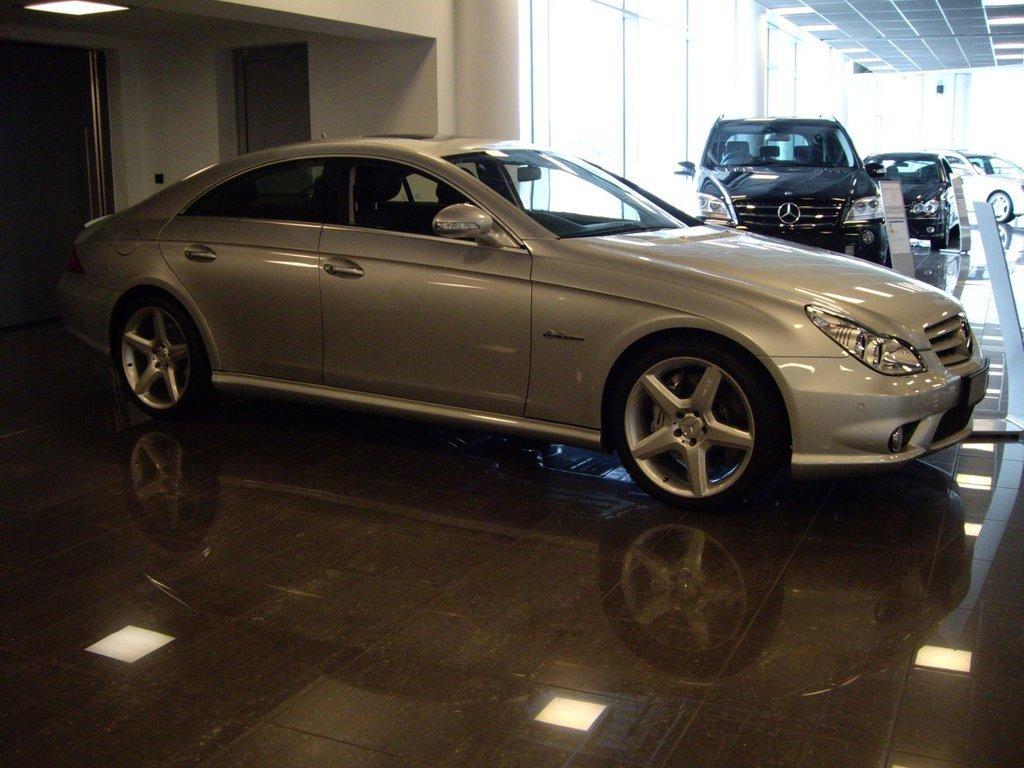Could you give a brief overview of what you see in this image? In this picture I can see there are cars parked here in the show room and there are glass doors and there is a wall. 